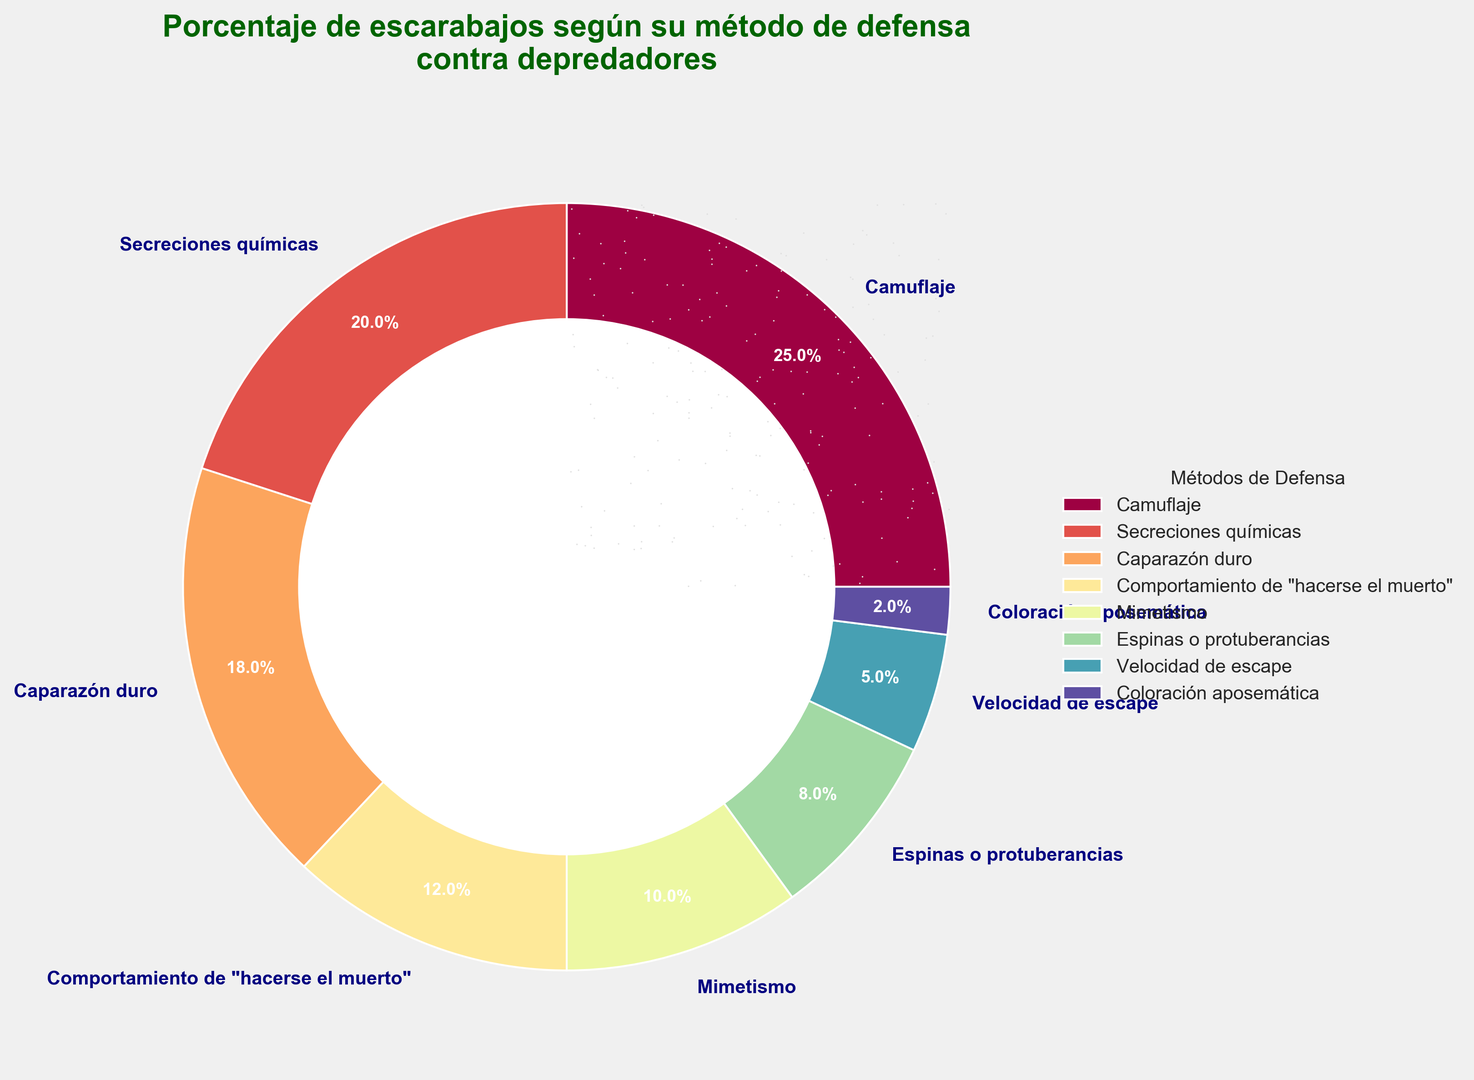¿Qué método de defensa tiene el mayor porcentaje de escarabajos? Al observar la gráfica, el segmento de la porción más grande corresponde al camuflaje. Este posee el 25%.
Answer: Camuflaje ¿Qué porcentaje de escarabajos utiliza secreciones químicas como método de defensa? El gráfico circular muestra un segmento etiquetado como secreciones químicas que tiene asignado el 20%.
Answer: 20% ¿Cuáles son los tres métodos de defensa más comunes según el porcentaje? Examinando los tamaños de los segmentos y sus etiquetas, los tres métodos más comunes son camuflaje (25%), secreciones químicas (20%) y caparazón duro (18%).
Answer: Camuflaje, secreciones químicas y caparazón duro ¿Cuál es la diferencia de porcentaje entre los escarabajos que usan camuflaje y aquellos que usan comportamiento de "hacerse el muerto"? El porcentaje para camuflaje es 25% y para comportamiento de "hacerse el muerto" es 12%. La diferencia es 25% - 12% = 13%.
Answer: 13% ¿Qué métodos de defensa tienen un porcentaje menor al 10%? Los métodos que tienen un porcentaje menor al 10% son mimetismo (10%), espinas o protuberancias (8%), velocidad de escape (5%) y coloración aposemática (2%).
Answer: Mimetismo, espinas o protuberancias, velocidad de escape y coloración aposemática ¿Cuál es el porcentaje total sumando los escarabajos que usan camuflaje y aquellos que tienen espinas o protuberancias? El porcentaje para camuflaje es 25% y para espinas o protuberancias es 8%. La suma es 25% + 8% = 33%.
Answer: 33% ¿Qué método de defensa tiene el menor porcentaje de escarabajos? El segmento más pequeño en la gráfica corresponde a la coloración aposemática, con un 2%.
Answer: Coloración aposemática Entre los métodos de camuflaje y velocidad de escape, ¿cuál tiene mayor porcentaje de uso? El camuflaje tiene un 25% y la velocidad de escape tiene un 5%. El camuflaje tiene un porcentaje más alto.
Answer: Camuflaje ¿Cómo se compara el porcentaje de escarabajos que usan caparazón duro frente a los que usan comportamiento de "hacerse el muerto"? El caparazón duro tiene un 18% y el comportamiento de "hacerse el muerto" tiene un 12%. El caparazón duro tiene un porcentaje mayor.
Answer: Caparazón duro ¿Qué métodos de defensa combinados superan el 50% del total de los escarabajos considerando los porcentajes de mayor a menor? Los métodos camuflaje (25%), secreciones químicas (20%) y caparazón duro (18%) combinados son 25% + 20% + 18% = 63%, superando el 50%.
Answer: Camuflaje, secreciones químicas y caparazón duro 